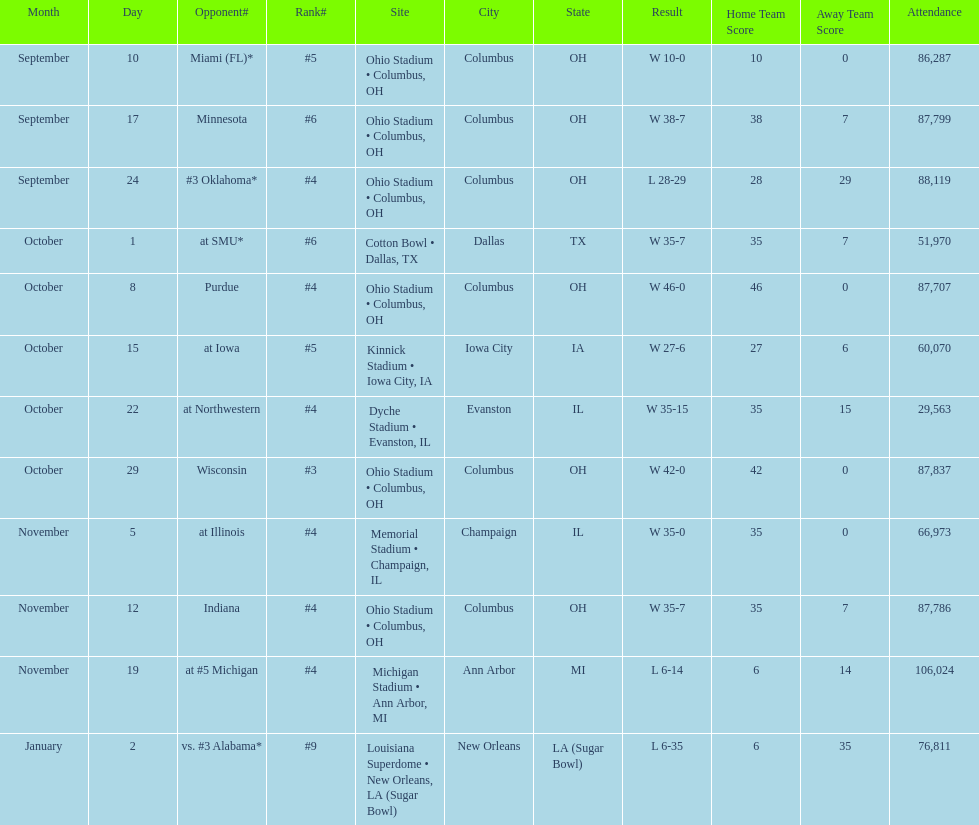What is the difference between the number of wins and the number of losses? 6. 